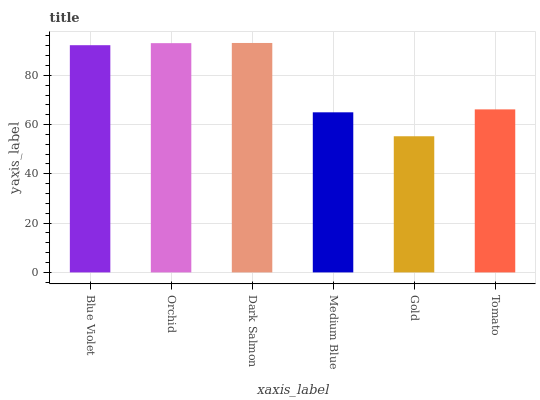Is Gold the minimum?
Answer yes or no. Yes. Is Dark Salmon the maximum?
Answer yes or no. Yes. Is Orchid the minimum?
Answer yes or no. No. Is Orchid the maximum?
Answer yes or no. No. Is Orchid greater than Blue Violet?
Answer yes or no. Yes. Is Blue Violet less than Orchid?
Answer yes or no. Yes. Is Blue Violet greater than Orchid?
Answer yes or no. No. Is Orchid less than Blue Violet?
Answer yes or no. No. Is Blue Violet the high median?
Answer yes or no. Yes. Is Tomato the low median?
Answer yes or no. Yes. Is Medium Blue the high median?
Answer yes or no. No. Is Dark Salmon the low median?
Answer yes or no. No. 